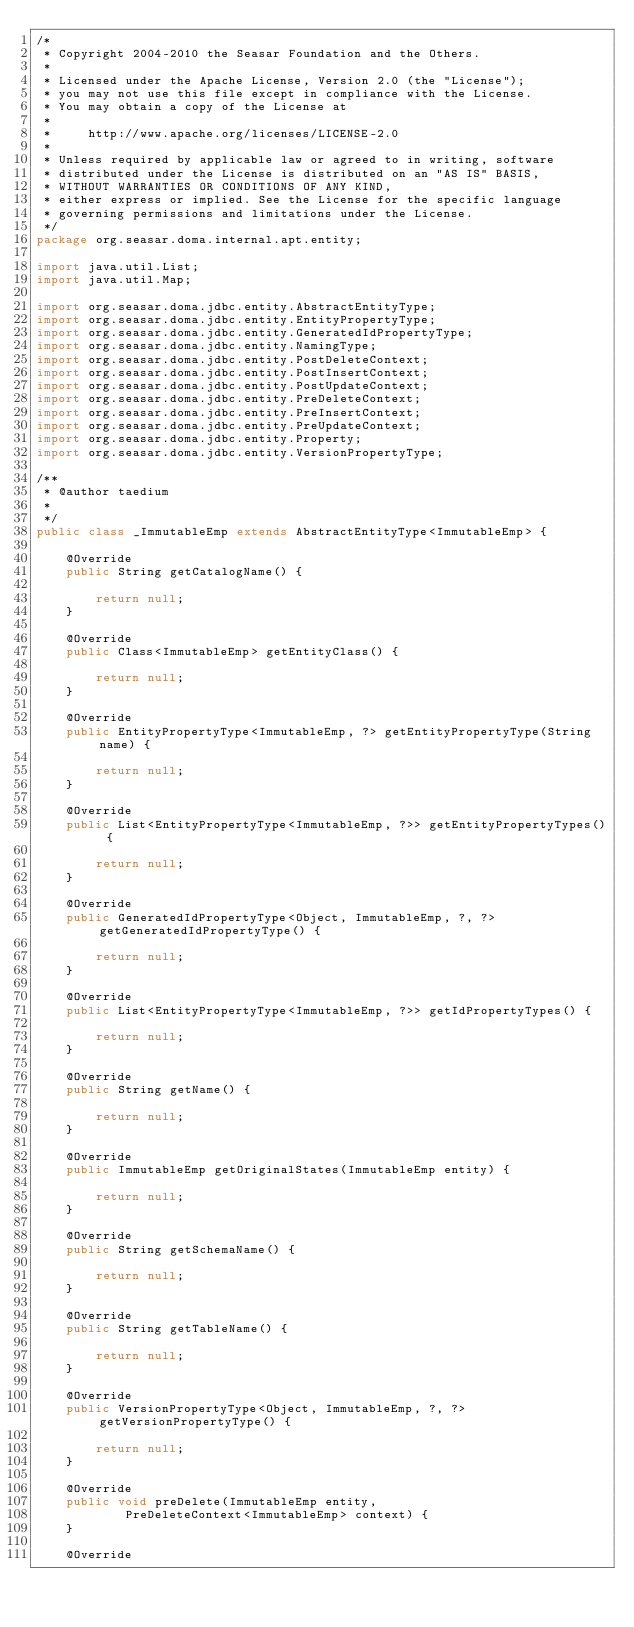Convert code to text. <code><loc_0><loc_0><loc_500><loc_500><_Java_>/*
 * Copyright 2004-2010 the Seasar Foundation and the Others.
 *
 * Licensed under the Apache License, Version 2.0 (the "License");
 * you may not use this file except in compliance with the License.
 * You may obtain a copy of the License at
 *
 *     http://www.apache.org/licenses/LICENSE-2.0
 *
 * Unless required by applicable law or agreed to in writing, software
 * distributed under the License is distributed on an "AS IS" BASIS,
 * WITHOUT WARRANTIES OR CONDITIONS OF ANY KIND,
 * either express or implied. See the License for the specific language
 * governing permissions and limitations under the License.
 */
package org.seasar.doma.internal.apt.entity;

import java.util.List;
import java.util.Map;

import org.seasar.doma.jdbc.entity.AbstractEntityType;
import org.seasar.doma.jdbc.entity.EntityPropertyType;
import org.seasar.doma.jdbc.entity.GeneratedIdPropertyType;
import org.seasar.doma.jdbc.entity.NamingType;
import org.seasar.doma.jdbc.entity.PostDeleteContext;
import org.seasar.doma.jdbc.entity.PostInsertContext;
import org.seasar.doma.jdbc.entity.PostUpdateContext;
import org.seasar.doma.jdbc.entity.PreDeleteContext;
import org.seasar.doma.jdbc.entity.PreInsertContext;
import org.seasar.doma.jdbc.entity.PreUpdateContext;
import org.seasar.doma.jdbc.entity.Property;
import org.seasar.doma.jdbc.entity.VersionPropertyType;

/**
 * @author taedium
 * 
 */
public class _ImmutableEmp extends AbstractEntityType<ImmutableEmp> {

    @Override
    public String getCatalogName() {

        return null;
    }

    @Override
    public Class<ImmutableEmp> getEntityClass() {

        return null;
    }

    @Override
    public EntityPropertyType<ImmutableEmp, ?> getEntityPropertyType(String name) {

        return null;
    }

    @Override
    public List<EntityPropertyType<ImmutableEmp, ?>> getEntityPropertyTypes() {

        return null;
    }

    @Override
    public GeneratedIdPropertyType<Object, ImmutableEmp, ?, ?> getGeneratedIdPropertyType() {

        return null;
    }

    @Override
    public List<EntityPropertyType<ImmutableEmp, ?>> getIdPropertyTypes() {

        return null;
    }

    @Override
    public String getName() {

        return null;
    }

    @Override
    public ImmutableEmp getOriginalStates(ImmutableEmp entity) {

        return null;
    }

    @Override
    public String getSchemaName() {

        return null;
    }

    @Override
    public String getTableName() {

        return null;
    }

    @Override
    public VersionPropertyType<Object, ImmutableEmp, ?, ?> getVersionPropertyType() {

        return null;
    }

    @Override
    public void preDelete(ImmutableEmp entity,
            PreDeleteContext<ImmutableEmp> context) {
    }

    @Override</code> 